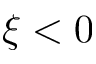Convert formula to latex. <formula><loc_0><loc_0><loc_500><loc_500>\xi < 0</formula> 